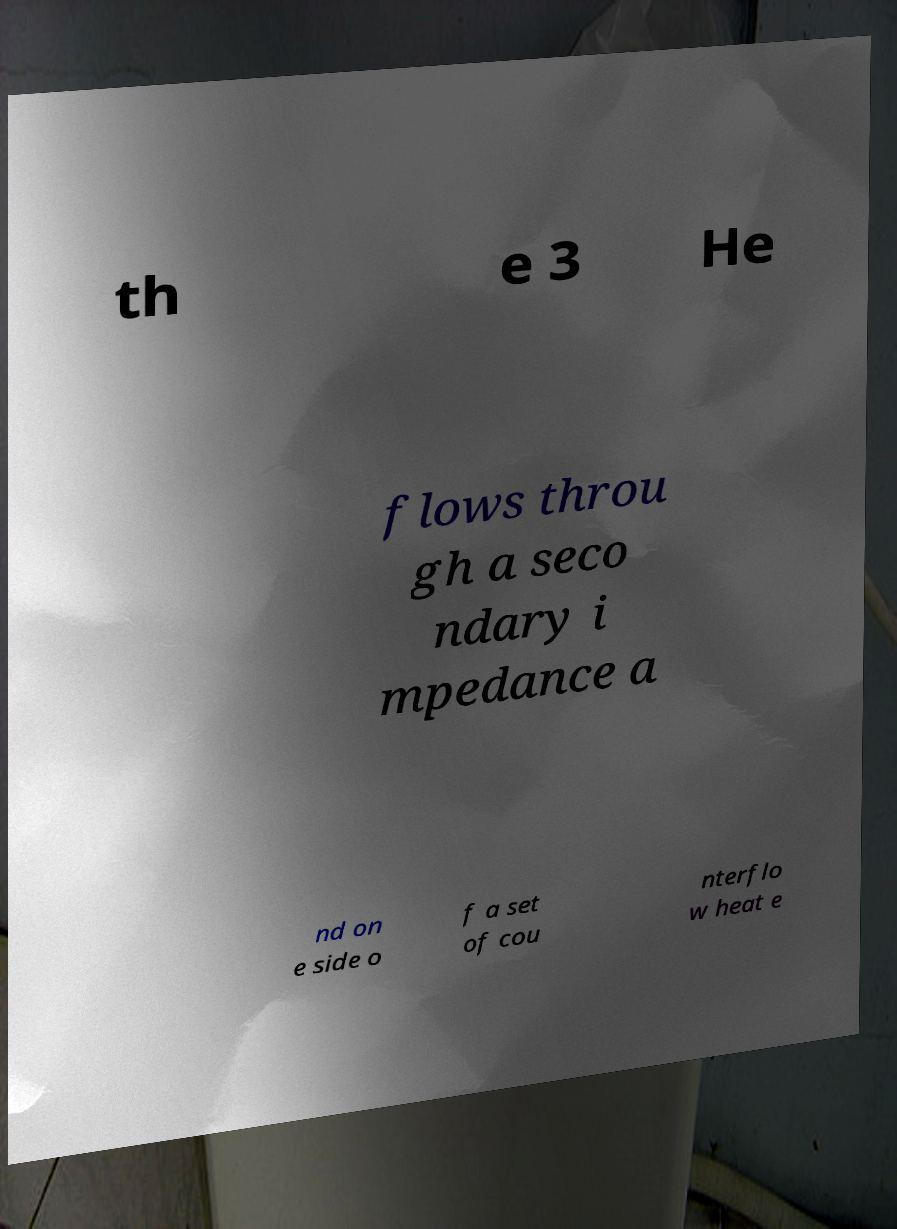I need the written content from this picture converted into text. Can you do that? th e 3 He flows throu gh a seco ndary i mpedance a nd on e side o f a set of cou nterflo w heat e 